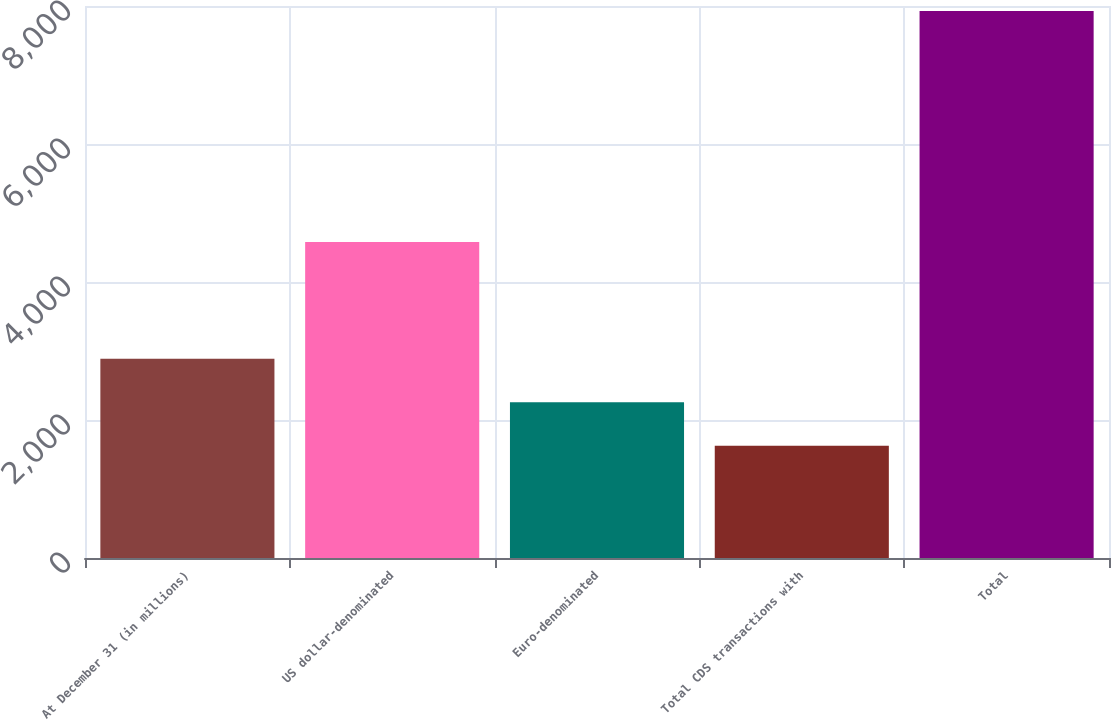<chart> <loc_0><loc_0><loc_500><loc_500><bar_chart><fcel>At December 31 (in millions)<fcel>US dollar-denominated<fcel>Euro-denominated<fcel>Total CDS transactions with<fcel>Total<nl><fcel>2886<fcel>4580<fcel>2256<fcel>1626<fcel>7926<nl></chart> 